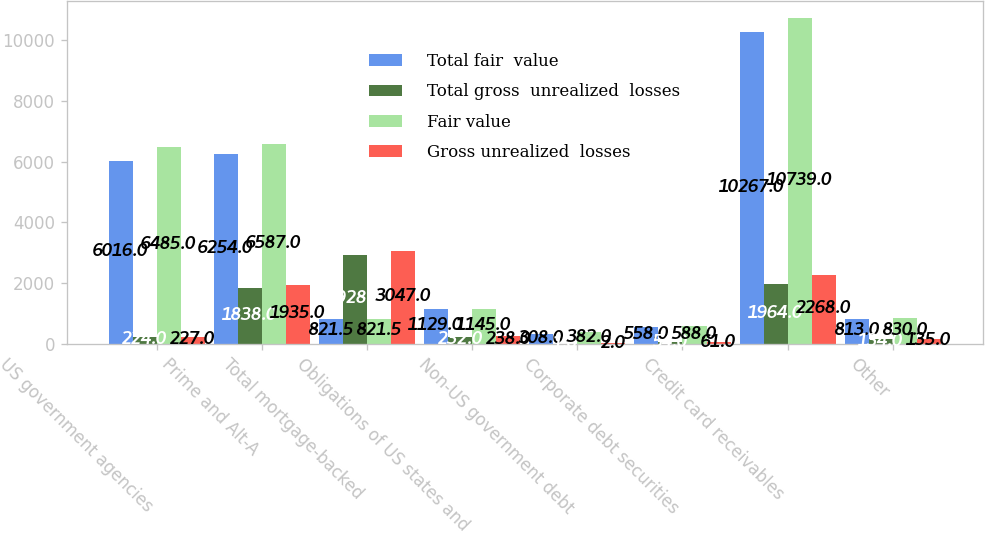<chart> <loc_0><loc_0><loc_500><loc_500><stacked_bar_chart><ecel><fcel>US government agencies<fcel>Prime and Alt-A<fcel>Total mortgage-backed<fcel>Obligations of US states and<fcel>Non-US government debt<fcel>Corporate debt securities<fcel>Credit card receivables<fcel>Other<nl><fcel>Total fair  value<fcel>6016<fcel>6254<fcel>821.5<fcel>1129<fcel>308<fcel>558<fcel>10267<fcel>813<nl><fcel>Total gross  unrealized  losses<fcel>224<fcel>1838<fcel>2928<fcel>232<fcel>1<fcel>54<fcel>1964<fcel>134<nl><fcel>Fair value<fcel>6485<fcel>6587<fcel>821.5<fcel>1145<fcel>382<fcel>588<fcel>10739<fcel>830<nl><fcel>Gross unrealized  losses<fcel>227<fcel>1935<fcel>3047<fcel>238<fcel>2<fcel>61<fcel>2268<fcel>135<nl></chart> 